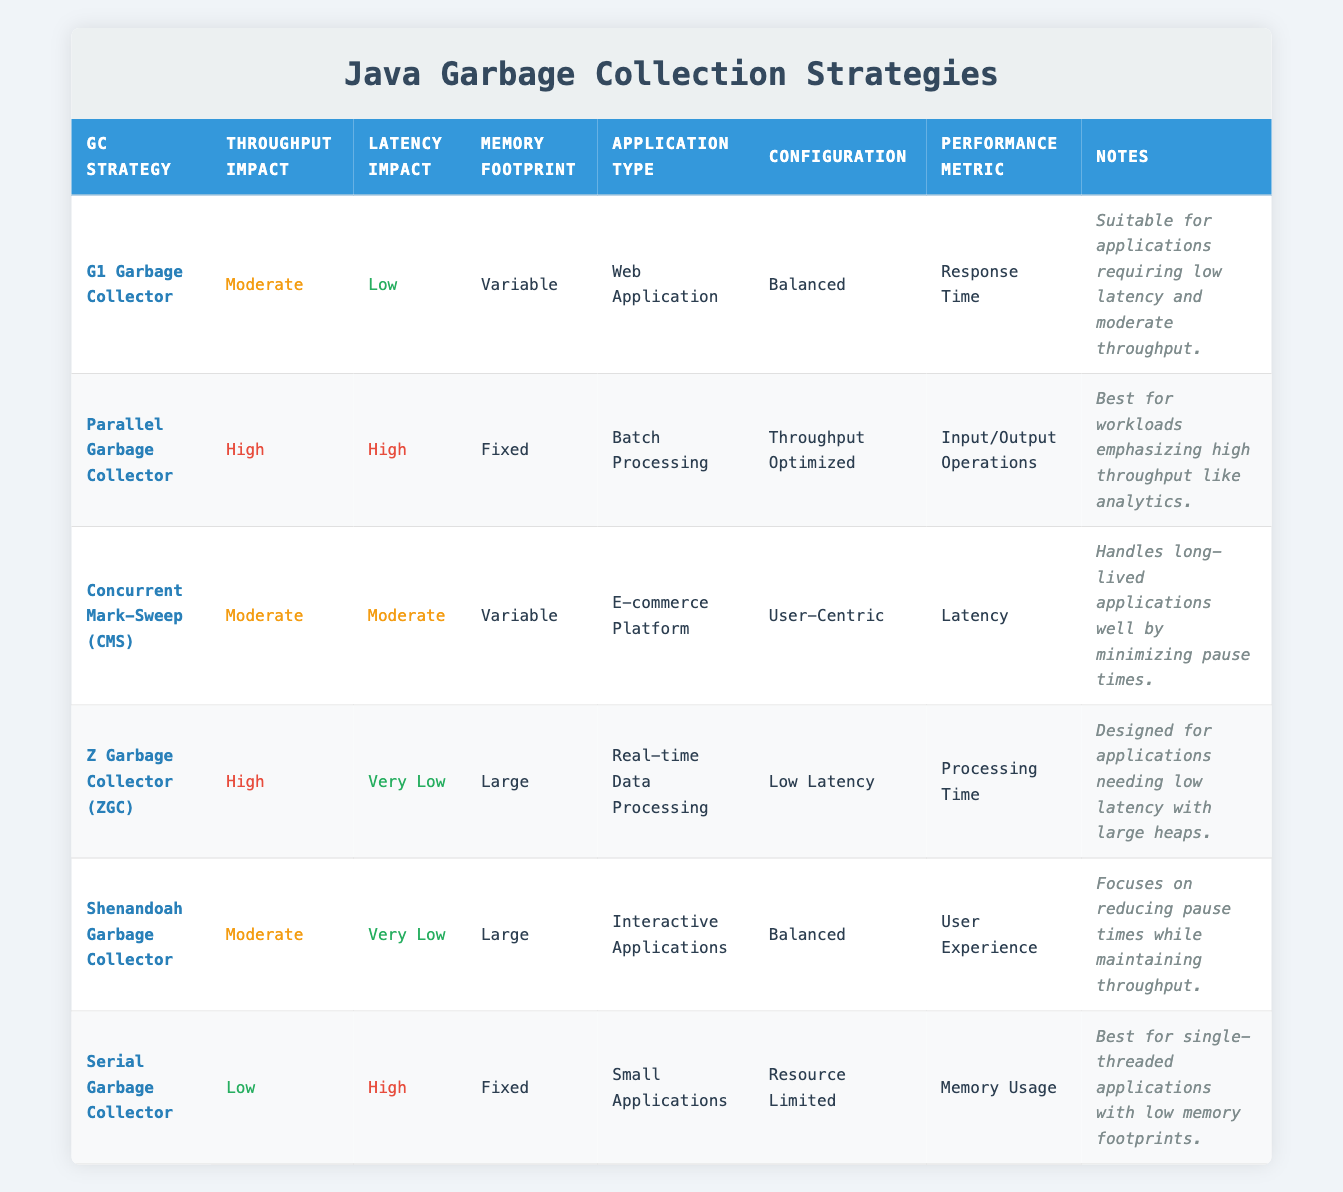What is the throughput impact of the G1 Garbage Collector? The G1 Garbage Collector has a throughput impact labeled as "Moderate" in the table. You can find this information in the row corresponding to the G1 Garbage Collector under the Throughput Impact column.
Answer: Moderate Which garbage collector has the lowest latency impact? The garbage collectors with the lowest latency impact listed in the table are Z Garbage Collector (ZGC) and Shenandoah Garbage Collector, both indicating "Very Low" in the Latency Impact column.
Answer: ZGC and Shenandoah Are all garbage collection strategies suitable for real-time data processing applications? No, only one garbage collector, Z Garbage Collector (ZGC), is explicitly listed in the table as suitable for real-time data processing under the Application Type.
Answer: No What is the memory footprint of the Parallel Garbage Collector? The Parallel Garbage Collector's memory footprint is described as "Fixed" in the table. This detail is found in the corresponding row for the Parallel Garbage Collector under the Memory Footprint column.
Answer: Fixed How many garbage collectors listed have a moderate throughput impact? There are three garbage collectors with a moderate throughput impact: G1 Garbage Collector, Concurrent Mark-Sweep (CMS), and Shenandoah Garbage Collector. Counting these entries from the table confirms this total.
Answer: Three Which configuration is used for the Serial Garbage Collector? The Serial Garbage Collector is configured with a "Resource Limited" setting. This is noted in its specific row under the Configuration column.
Answer: Resource Limited Is the G1 Garbage Collector suitable for applications requiring low latency and high throughput? No, the G1 Garbage Collector is noted as suitable for low latency and moderate throughput applications, thus it does not meet the requirement for high throughput.
Answer: No What performance metric is prioritized by the Shenandoah Garbage Collector? The performance metric for the Shenandoah Garbage Collector is "User Experience," which is indicated in the table under its respective row.
Answer: User Experience How does the latency impact of the Concurrent Mark-Sweep (CMS) compare to the Parallel Garbage Collector? The latency impact of Concurrent Mark-Sweep (CMS) is "Moderate," whereas for the Parallel Garbage Collector, it is "High." Since "Moderate" indicates less impact than "High," this shows that the CMS has a comparatively lower latency impact.
Answer: Lower 